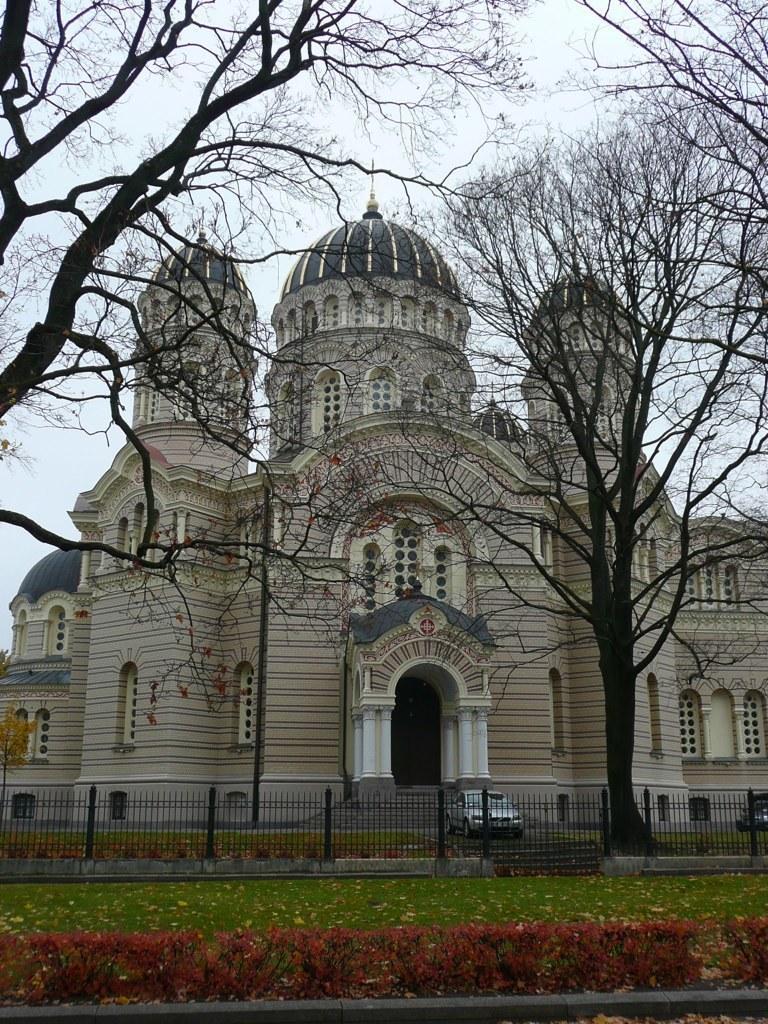Can you describe this image briefly? In the background of the image there is a building. There is a car. There is a metal railing. At the bottom of the image there is grass, plants. In the center of the image there are dried trees. 